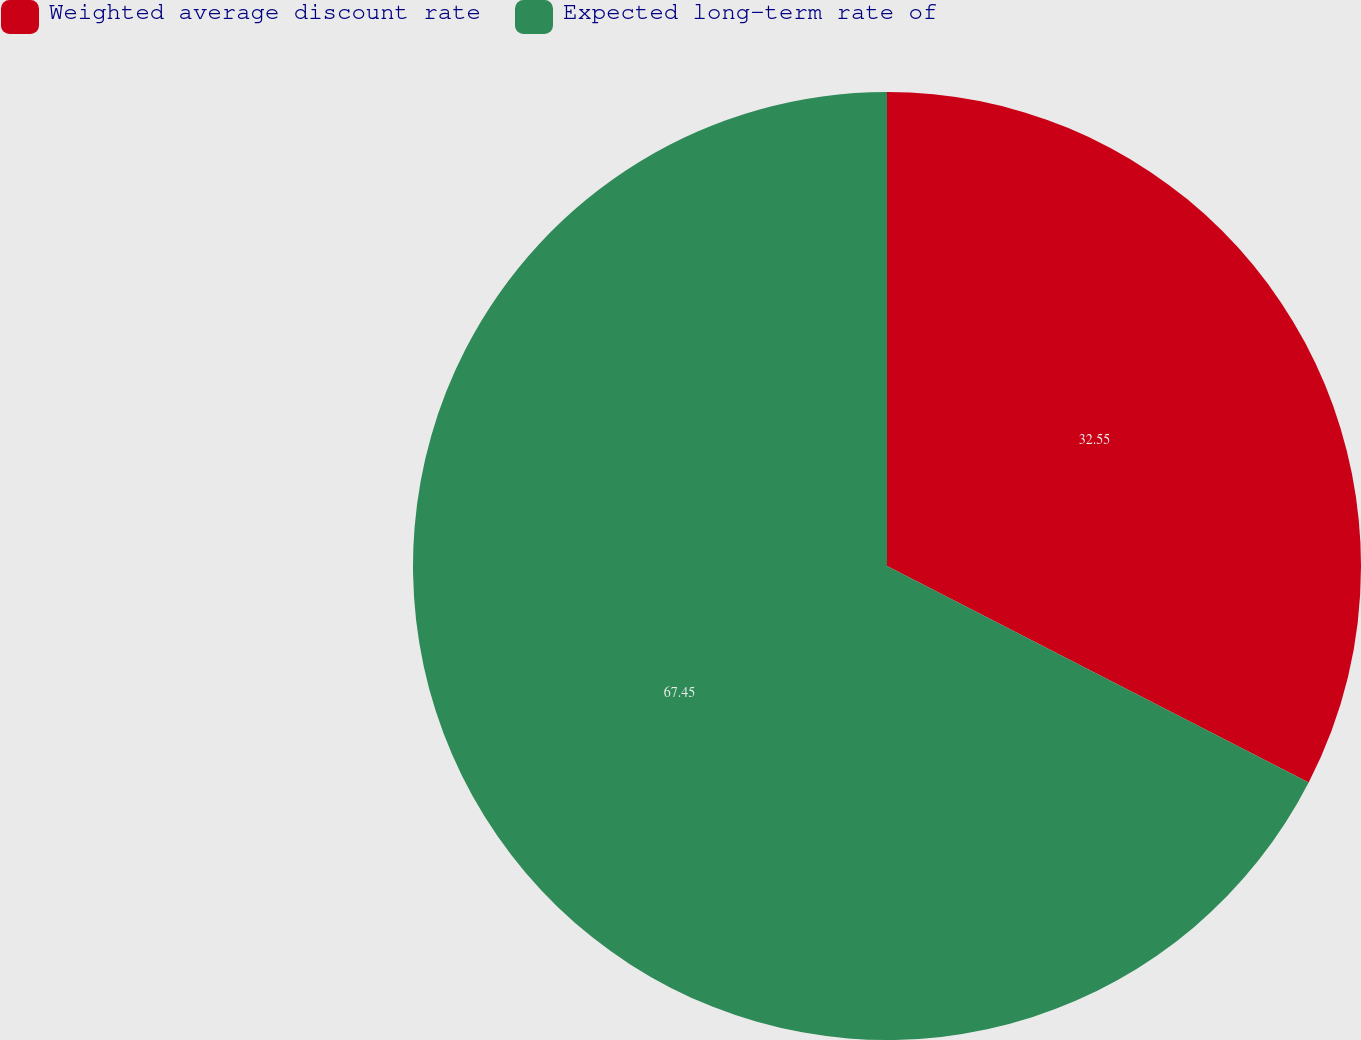Convert chart. <chart><loc_0><loc_0><loc_500><loc_500><pie_chart><fcel>Weighted average discount rate<fcel>Expected long-term rate of<nl><fcel>32.55%<fcel>67.45%<nl></chart> 